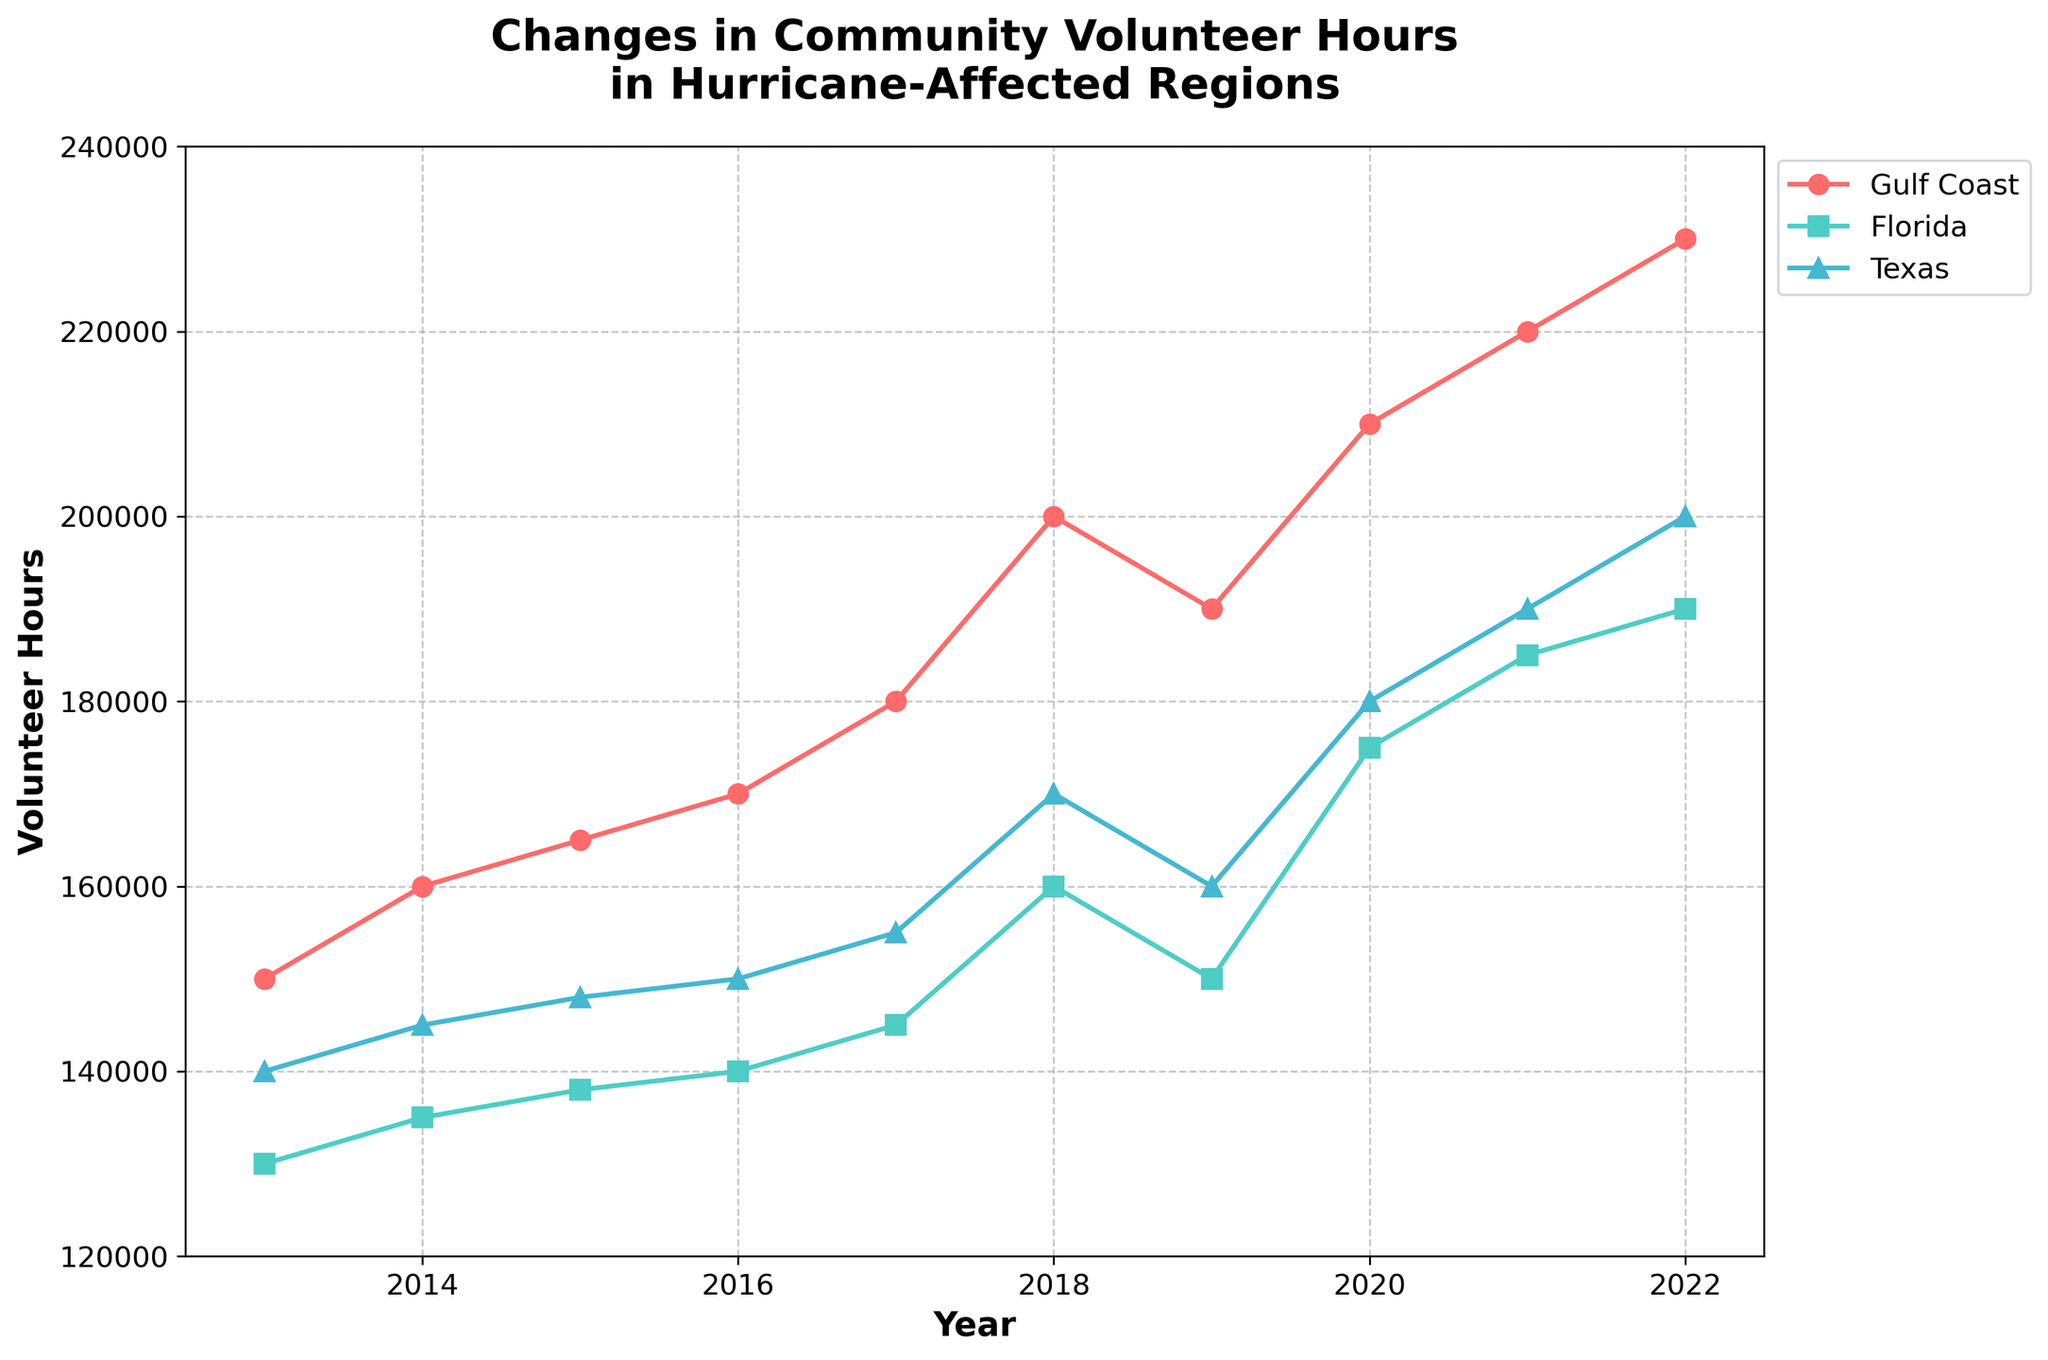What's the title of the plot? The title is prominently displayed at the top of the plot for clarity and context. It reads 'Changes in Community Volunteer Hours in Hurricane-Affected Regions'.
Answer: Changes in Community Volunteer Hours in Hurricane-Affected Regions What is the range of years presented in the plot? The x-axis of the plot shows years, which help us determine the range. By looking at the years displayed along the x-axis, the range extends from 2013 to 2022.
Answer: 2013 to 2022 How many regions are shown in the plot, and can you name them? The legend on the plot lists the regions displayed. Each region has a unique color and marker. The regions shown are the Gulf Coast, Florida, and Texas.
Answer: Three: Gulf Coast, Florida, Texas Which region had the highest volunteer hours in 2022? By comparing the endpoints of the lines on the plot for each region in 2022, it's clear that the Gulf Coast had the highest volunteer hours.
Answer: Gulf Coast What is the average number of volunteer hours for Florida over the decade? Find Florida's volunteer hours for each year, sum them up, and divide by the number of years. (130000 + 135000 + 138000 + 140000 + 145000 + 160000 + 150000 + 175000 + 185000 + 190000 = 1448000; 1448000/10 = 144800)
Answer: 144800 How did the volunteer hours change in the Gulf Coast from 2018 to 2019? Look at the values for the Gulf Coast in 2018 and 2019. In 2018 it was 200000, and in 2019 it was 190000. The volunteer hours decreased by 10000.
Answer: Decreased by 10000 Between Texas and Florida, which region showed a greater increase in volunteer hours from 2017 to 2018? For Texas, the increase is 170000 - 155000 = 15000. For Florida, the increase is 160000 - 145000 = 15000. Both regions had the same increase of 15000 volunteer hours.
Answer: Both increased by 15000 What was the overall trend in volunteer hours for the Gulf Coast over the decade? Look at the Gulf Coast line from 2013 to 2022. The line is generally upward sloping, indicating a consistent increase in volunteer hours over the decade.
Answer: Increasing trend How do the volunteer hours in 2015 compare among the three regions? Check the plot values for 2015. For Gulf Coast, it's 165000; for Florida, it's 138000; for Texas, it's 148000. The Gulf Coast has the most, followed by Texas, and then Florida.
Answer: Gulf Coast > Texas > Florida What was the total increase in volunteer hours for Texas from 2013 to 2022? Subtract the 2013 value from the 2022 value for Texas. (200000 - 140000 = 60000)
Answer: 60000 